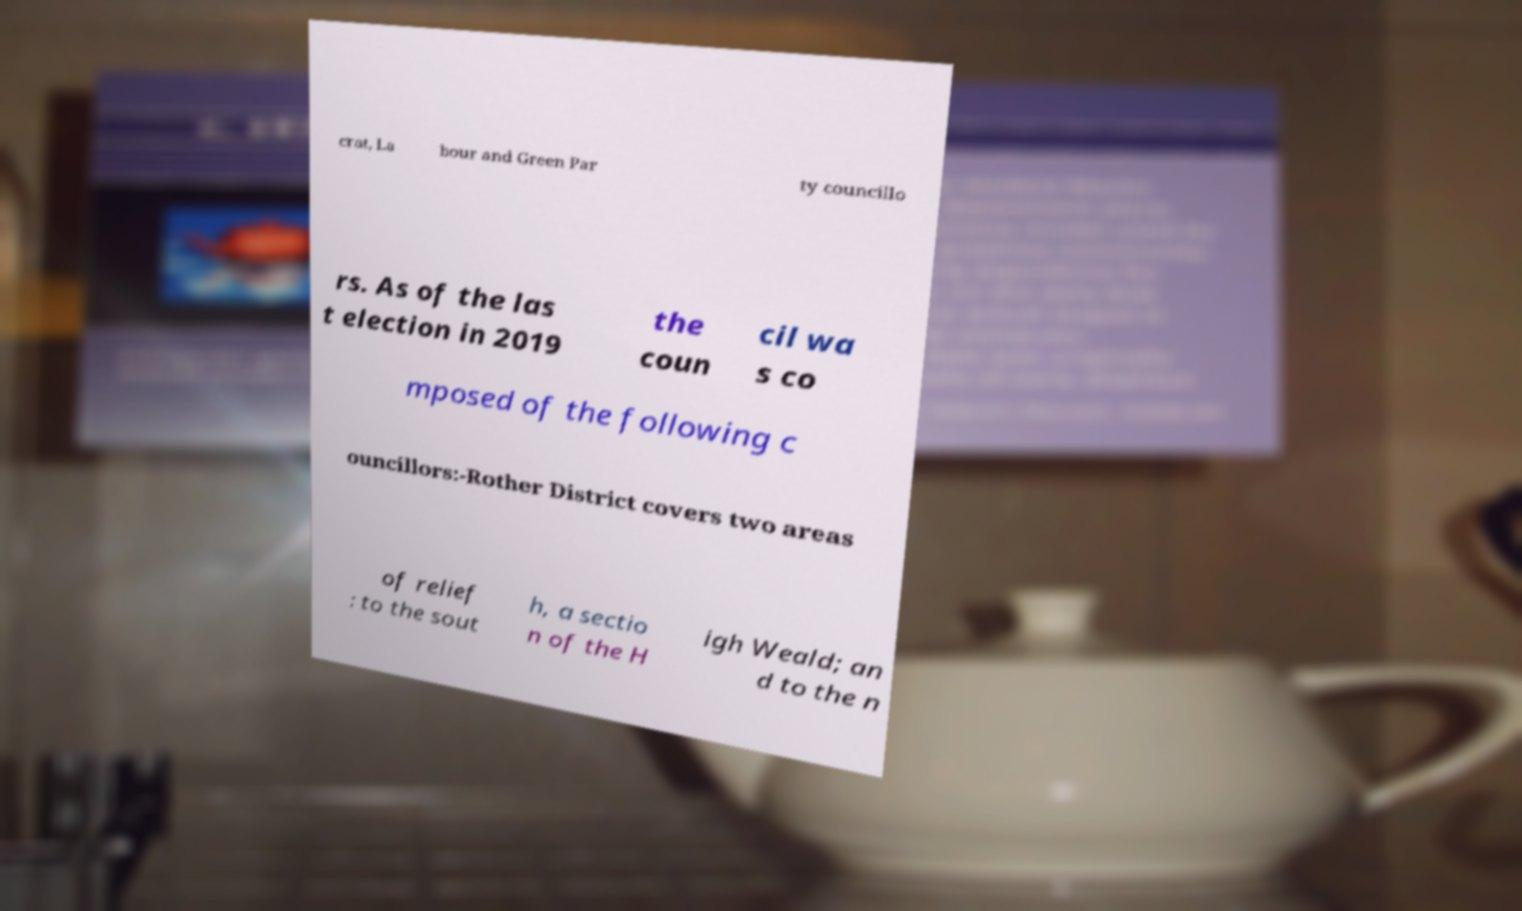Can you accurately transcribe the text from the provided image for me? crat, La bour and Green Par ty councillo rs. As of the las t election in 2019 the coun cil wa s co mposed of the following c ouncillors:-Rother District covers two areas of relief : to the sout h, a sectio n of the H igh Weald; an d to the n 